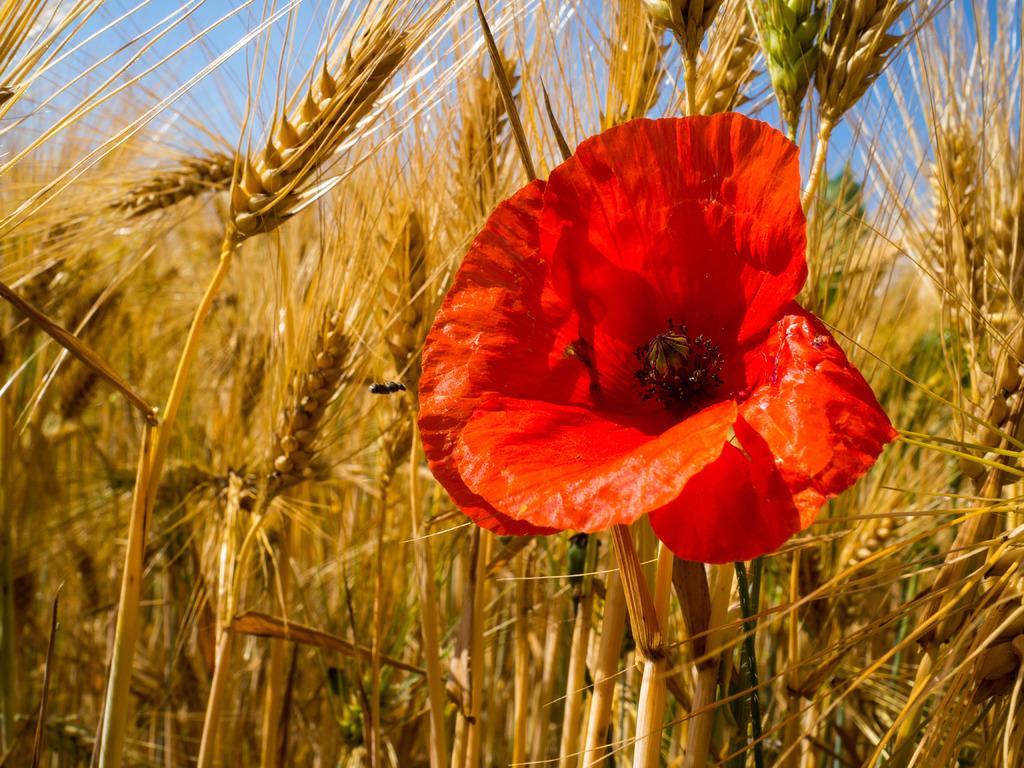In one or two sentences, can you explain what this image depicts? Here we can see a flower and wheat field. In the background there is sky. 